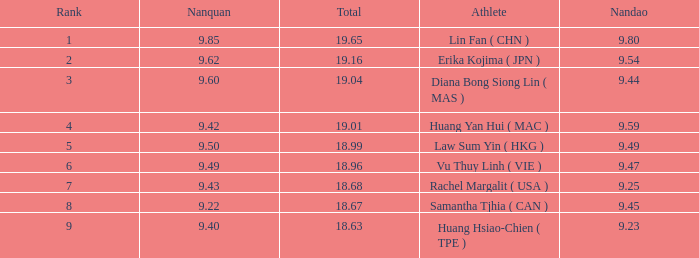Which Nanquan has a Nandao smaller than 9.44, and a Rank smaller than 9, and a Total larger than 18.68? None. 